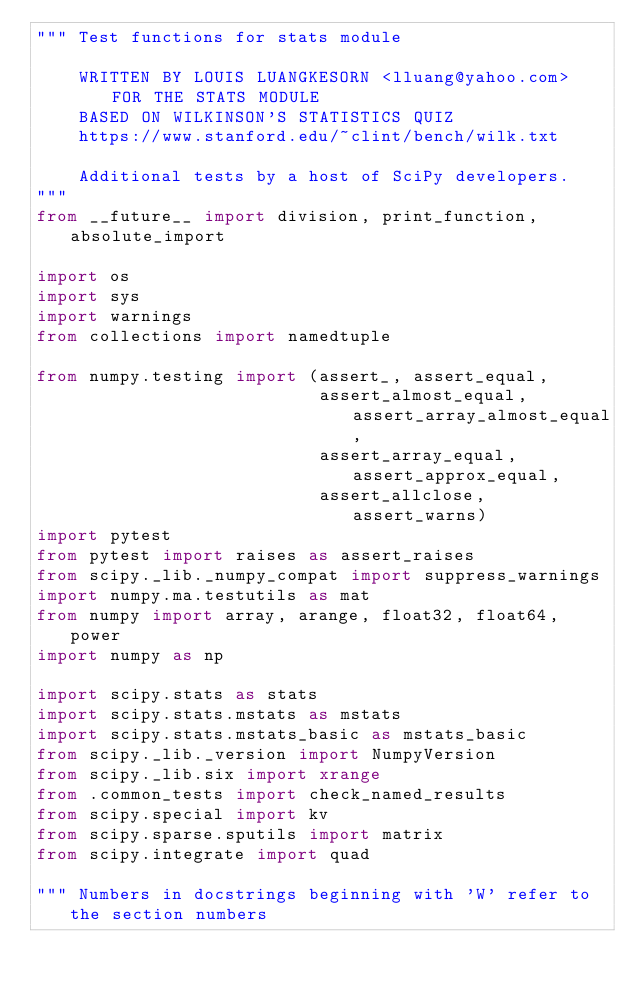Convert code to text. <code><loc_0><loc_0><loc_500><loc_500><_Python_>""" Test functions for stats module

    WRITTEN BY LOUIS LUANGKESORN <lluang@yahoo.com> FOR THE STATS MODULE
    BASED ON WILKINSON'S STATISTICS QUIZ
    https://www.stanford.edu/~clint/bench/wilk.txt

    Additional tests by a host of SciPy developers.
"""
from __future__ import division, print_function, absolute_import

import os
import sys
import warnings
from collections import namedtuple

from numpy.testing import (assert_, assert_equal,
                           assert_almost_equal, assert_array_almost_equal,
                           assert_array_equal, assert_approx_equal,
                           assert_allclose, assert_warns)
import pytest
from pytest import raises as assert_raises
from scipy._lib._numpy_compat import suppress_warnings
import numpy.ma.testutils as mat
from numpy import array, arange, float32, float64, power
import numpy as np

import scipy.stats as stats
import scipy.stats.mstats as mstats
import scipy.stats.mstats_basic as mstats_basic
from scipy._lib._version import NumpyVersion
from scipy._lib.six import xrange
from .common_tests import check_named_results
from scipy.special import kv
from scipy.sparse.sputils import matrix
from scipy.integrate import quad

""" Numbers in docstrings beginning with 'W' refer to the section numbers</code> 